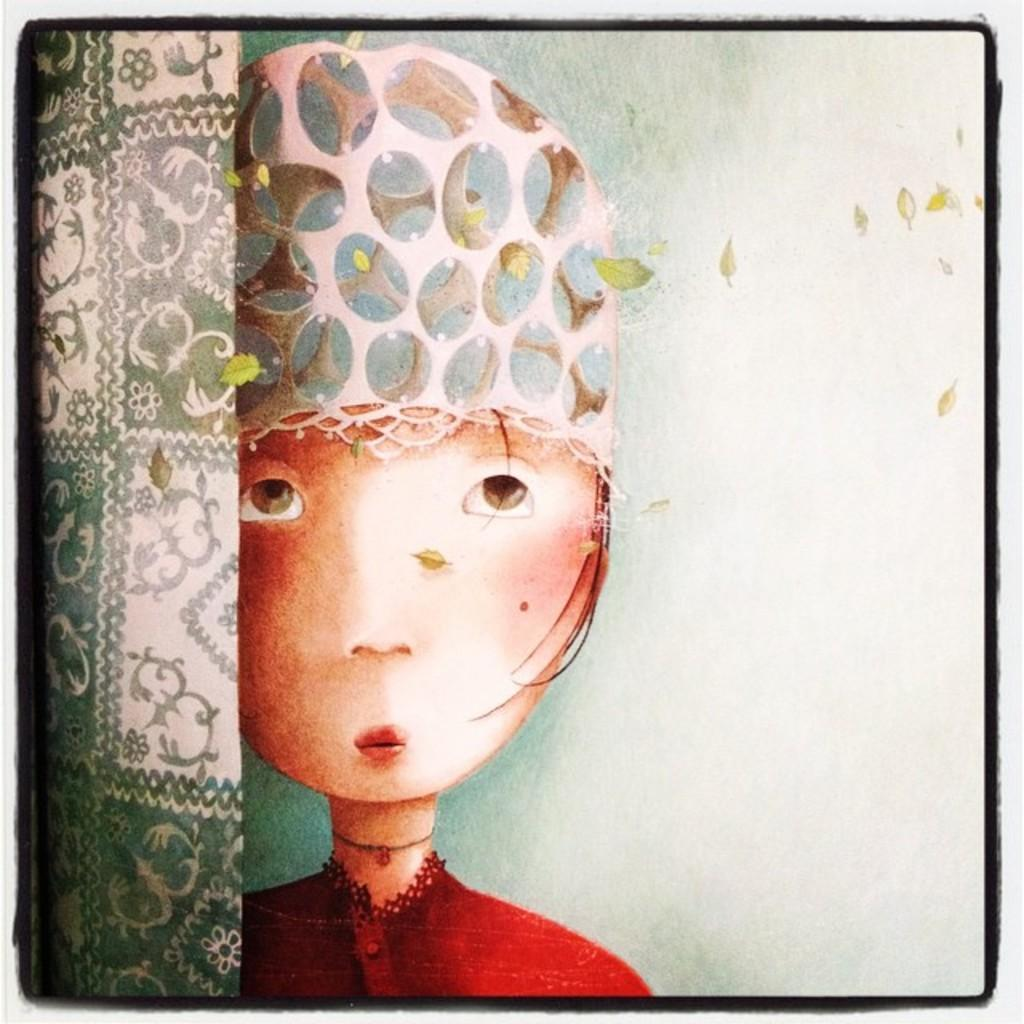What is the overall structure of the image? The image has borders. What type of artwork is present in the image? There is a painting of a person and paintings of objects in the image. Are there any natural elements depicted in the image? Yes, there are leaves depicted in the image. How many horses are depicted in the image? There are no horses present in the image. Can you tell me which character in the painting is about to sneeze? There is no indication in the image that any character is about to sneeze. 